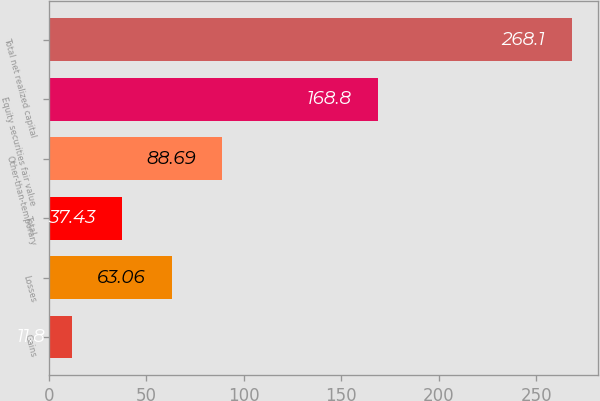<chart> <loc_0><loc_0><loc_500><loc_500><bar_chart><fcel>Gains<fcel>Losses<fcel>Total<fcel>Other-than-temporary<fcel>Equity securities fair value<fcel>Total net realized capital<nl><fcel>11.8<fcel>63.06<fcel>37.43<fcel>88.69<fcel>168.8<fcel>268.1<nl></chart> 